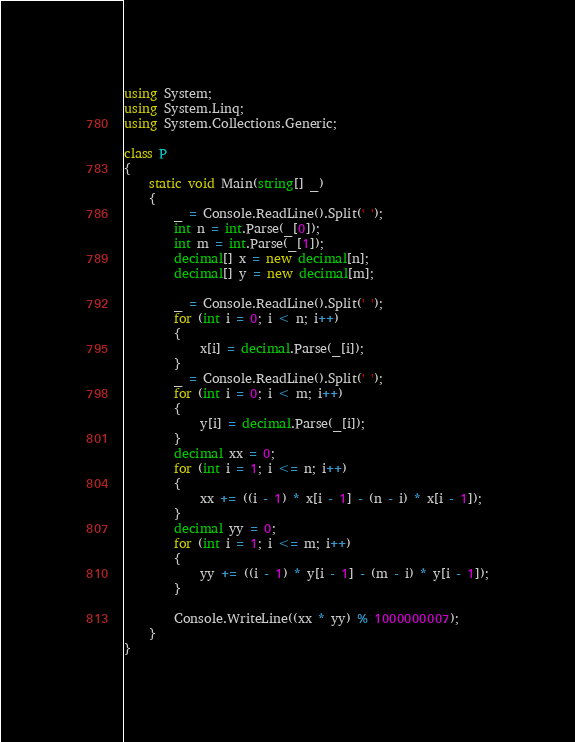<code> <loc_0><loc_0><loc_500><loc_500><_C#_>using System;
using System.Linq;
using System.Collections.Generic;

class P
{
    static void Main(string[] _)
    {
        _ = Console.ReadLine().Split(' ');
        int n = int.Parse(_[0]);
        int m = int.Parse(_[1]);
        decimal[] x = new decimal[n];
        decimal[] y = new decimal[m];

        _ = Console.ReadLine().Split(' ');
        for (int i = 0; i < n; i++)
        {
            x[i] = decimal.Parse(_[i]);
        }
        _ = Console.ReadLine().Split(' ');
        for (int i = 0; i < m; i++)
        {
            y[i] = decimal.Parse(_[i]);
        }
        decimal xx = 0;
        for (int i = 1; i <= n; i++)
        {
            xx += ((i - 1) * x[i - 1] - (n - i) * x[i - 1]);
        }
        decimal yy = 0;
        for (int i = 1; i <= m; i++)
        {
            yy += ((i - 1) * y[i - 1] - (m - i) * y[i - 1]);
        }

        Console.WriteLine((xx * yy) % 1000000007);
    }
}
</code> 